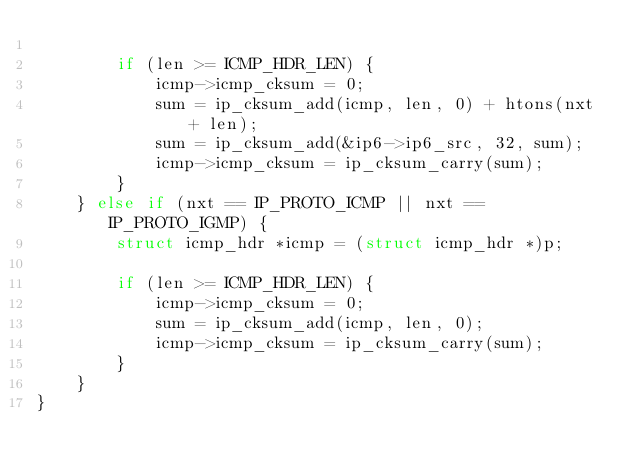<code> <loc_0><loc_0><loc_500><loc_500><_C_>
		if (len >= ICMP_HDR_LEN) {
			icmp->icmp_cksum = 0;
			sum = ip_cksum_add(icmp, len, 0) + htons(nxt + len);
			sum = ip_cksum_add(&ip6->ip6_src, 32, sum);
			icmp->icmp_cksum = ip_cksum_carry(sum);
		}		
	} else if (nxt == IP_PROTO_ICMP || nxt == IP_PROTO_IGMP) {
		struct icmp_hdr *icmp = (struct icmp_hdr *)p;
		
		if (len >= ICMP_HDR_LEN) {
			icmp->icmp_cksum = 0;
			sum = ip_cksum_add(icmp, len, 0);
			icmp->icmp_cksum = ip_cksum_carry(sum);
		}
	}
}
</code> 